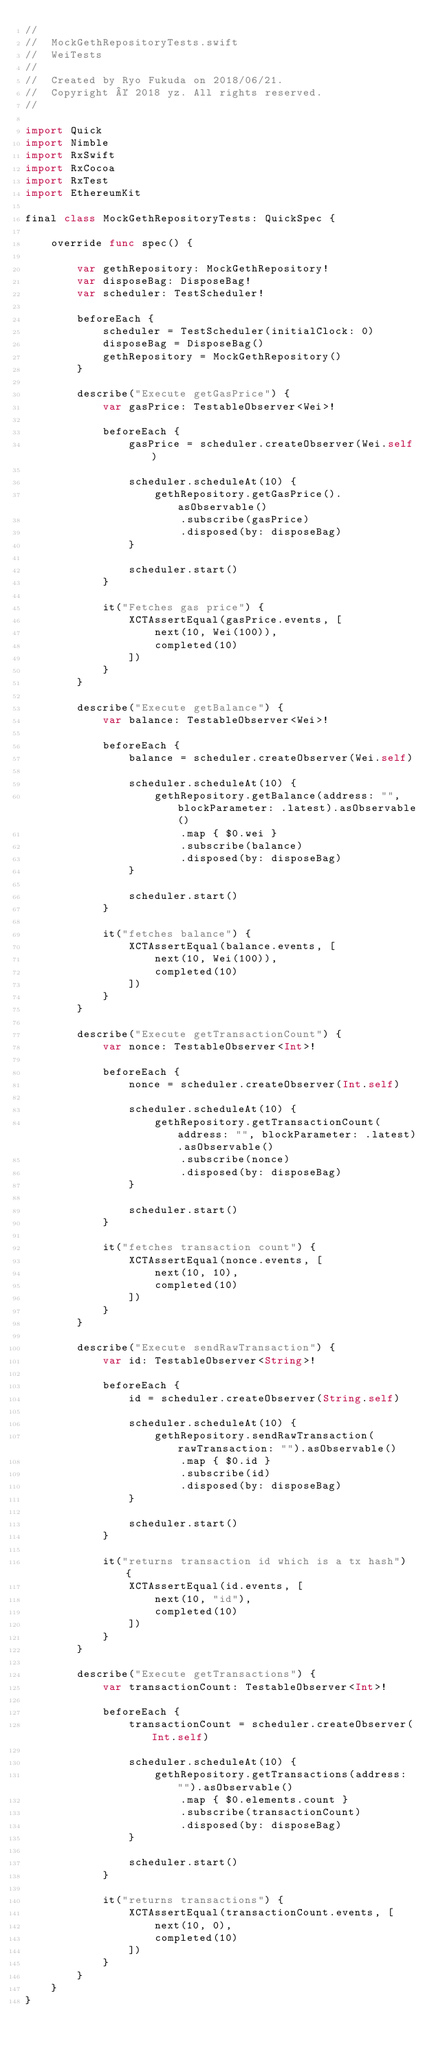Convert code to text. <code><loc_0><loc_0><loc_500><loc_500><_Swift_>//
//  MockGethRepositoryTests.swift
//  WeiTests
//
//  Created by Ryo Fukuda on 2018/06/21.
//  Copyright © 2018 yz. All rights reserved.
//

import Quick
import Nimble
import RxSwift
import RxCocoa
import RxTest
import EthereumKit

final class MockGethRepositoryTests: QuickSpec {
    
    override func spec() {
        
        var gethRepository: MockGethRepository!
        var disposeBag: DisposeBag!
        var scheduler: TestScheduler!
        
        beforeEach {
            scheduler = TestScheduler(initialClock: 0)
            disposeBag = DisposeBag()
            gethRepository = MockGethRepository()
        }
        
        describe("Execute getGasPrice") {
            var gasPrice: TestableObserver<Wei>!
            
            beforeEach {
                gasPrice = scheduler.createObserver(Wei.self)
                
                scheduler.scheduleAt(10) {
                    gethRepository.getGasPrice().asObservable()
                        .subscribe(gasPrice)
                        .disposed(by: disposeBag)
                }
                
                scheduler.start()
            }
            
            it("Fetches gas price") {
                XCTAssertEqual(gasPrice.events, [
                    next(10, Wei(100)),
                    completed(10)
                ])
            }
        }
        
        describe("Execute getBalance") {
            var balance: TestableObserver<Wei>!
            
            beforeEach {
                balance = scheduler.createObserver(Wei.self)
                
                scheduler.scheduleAt(10) {
                    gethRepository.getBalance(address: "", blockParameter: .latest).asObservable()
                        .map { $0.wei }
                        .subscribe(balance)
                        .disposed(by: disposeBag)
                }
                
                scheduler.start()
            }
            
            it("fetches balance") {
                XCTAssertEqual(balance.events, [
                    next(10, Wei(100)),
                    completed(10)
                ])
            }
        }
        
        describe("Execute getTransactionCount") {
            var nonce: TestableObserver<Int>!
            
            beforeEach {
                nonce = scheduler.createObserver(Int.self)
                
                scheduler.scheduleAt(10) {
                    gethRepository.getTransactionCount(address: "", blockParameter: .latest).asObservable()
                        .subscribe(nonce)
                        .disposed(by: disposeBag)
                }
                
                scheduler.start()
            }
            
            it("fetches transaction count") {
                XCTAssertEqual(nonce.events, [
                    next(10, 10),
                    completed(10)
                ])
            }
        }
        
        describe("Execute sendRawTransaction") {
            var id: TestableObserver<String>!
            
            beforeEach {
                id = scheduler.createObserver(String.self)
                
                scheduler.scheduleAt(10) {
                    gethRepository.sendRawTransaction(rawTransaction: "").asObservable()
                        .map { $0.id }
                        .subscribe(id)
                        .disposed(by: disposeBag)
                }
                
                scheduler.start()
            }
            
            it("returns transaction id which is a tx hash") {
                XCTAssertEqual(id.events, [
                    next(10, "id"),
                    completed(10)
                ])
            }
        }
        
        describe("Execute getTransactions") {
            var transactionCount: TestableObserver<Int>!
            
            beforeEach {
                transactionCount = scheduler.createObserver(Int.self)
                
                scheduler.scheduleAt(10) {
                    gethRepository.getTransactions(address: "").asObservable()
                        .map { $0.elements.count }
                        .subscribe(transactionCount)
                        .disposed(by: disposeBag)
                }
                
                scheduler.start()
            }
            
            it("returns transactions") {
                XCTAssertEqual(transactionCount.events, [
                    next(10, 0),
                    completed(10)
                ])
            }
        }
    }
}
</code> 